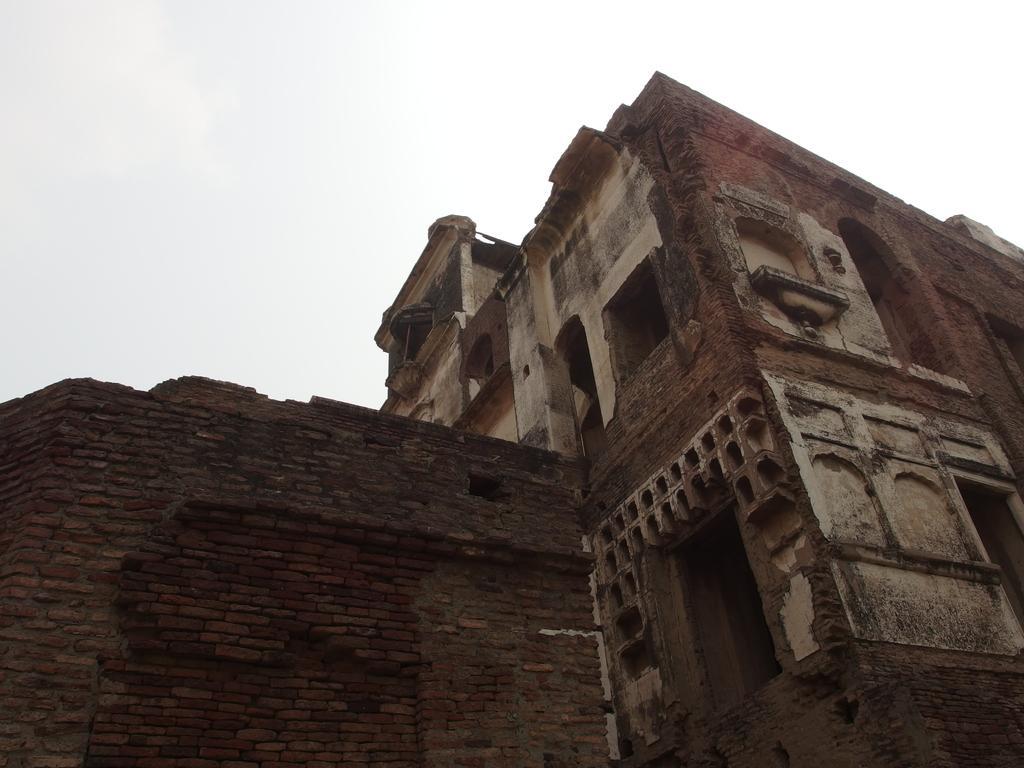Please provide a concise description of this image. In this picture there is an old building on the right side of the image and there is a wall on the left side of the image. 